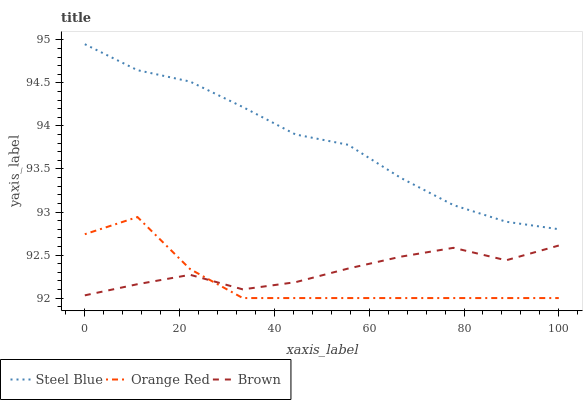Does Orange Red have the minimum area under the curve?
Answer yes or no. Yes. Does Steel Blue have the maximum area under the curve?
Answer yes or no. Yes. Does Steel Blue have the minimum area under the curve?
Answer yes or no. No. Does Orange Red have the maximum area under the curve?
Answer yes or no. No. Is Steel Blue the smoothest?
Answer yes or no. Yes. Is Orange Red the roughest?
Answer yes or no. Yes. Is Orange Red the smoothest?
Answer yes or no. No. Is Steel Blue the roughest?
Answer yes or no. No. Does Orange Red have the lowest value?
Answer yes or no. Yes. Does Steel Blue have the lowest value?
Answer yes or no. No. Does Steel Blue have the highest value?
Answer yes or no. Yes. Does Orange Red have the highest value?
Answer yes or no. No. Is Orange Red less than Steel Blue?
Answer yes or no. Yes. Is Steel Blue greater than Brown?
Answer yes or no. Yes. Does Orange Red intersect Brown?
Answer yes or no. Yes. Is Orange Red less than Brown?
Answer yes or no. No. Is Orange Red greater than Brown?
Answer yes or no. No. Does Orange Red intersect Steel Blue?
Answer yes or no. No. 